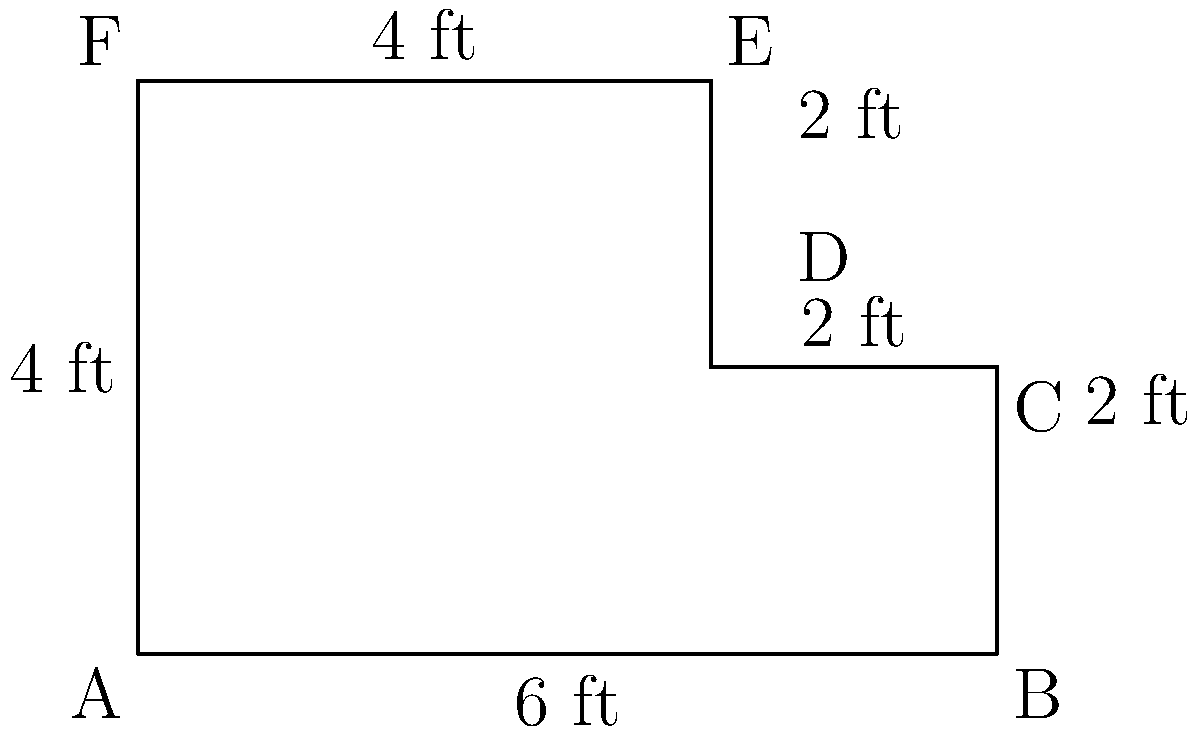You've discovered a unique, irregularly shaped vintage bookshelf for your airport bookstore. The bookshelf's outline is shown in the diagram above. What is the perimeter of this bookshelf in feet? To calculate the perimeter of the irregularly shaped bookshelf, we need to sum up the lengths of all its sides:

1. Bottom side (AB): $6$ ft
2. Right side, lower part (BC): $2$ ft
3. Top side, right part (CD): $2$ ft
4. Right side, upper part (DE): $2$ ft
5. Top side, left part (EF): $4$ ft
6. Left side (FA): $4$ ft

Now, let's add all these lengths:

$$ \text{Perimeter} = 6 + 2 + 2 + 2 + 4 + 4 = 20 \text{ ft} $$

Therefore, the perimeter of the vintage bookshelf is 20 feet.
Answer: 20 ft 